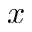Convert formula to latex. <formula><loc_0><loc_0><loc_500><loc_500>x</formula> 